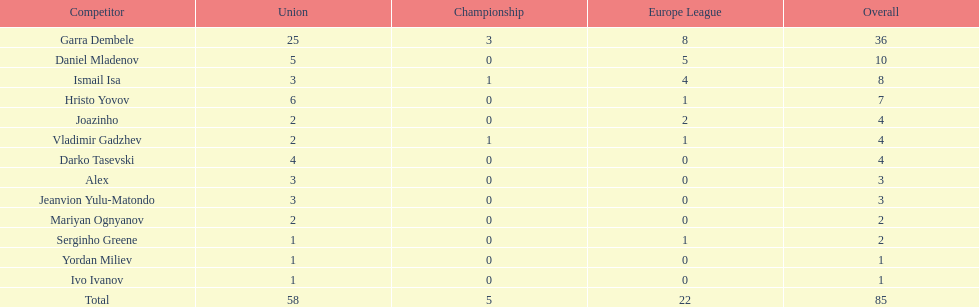Which players only scored one goal? Serginho Greene, Yordan Miliev, Ivo Ivanov. 